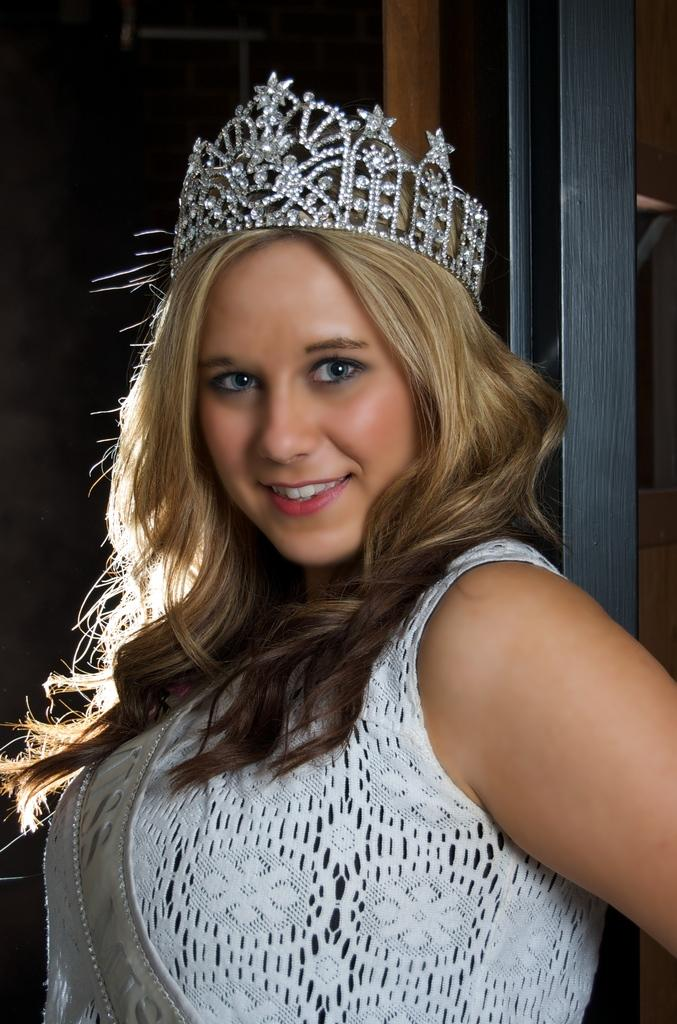Who is the main subject in the image? There is a lady standing in the center of the image. What is the lady wearing on her head? The lady is wearing a crown. What can be seen in the background of the image? There is a door in the background of the image. Where is the lady's sister in the image? There is no mention of a sister in the image, so we cannot determine her location. What type of fruit is on the bed in the image? There is no bed or fruit present in the image. 